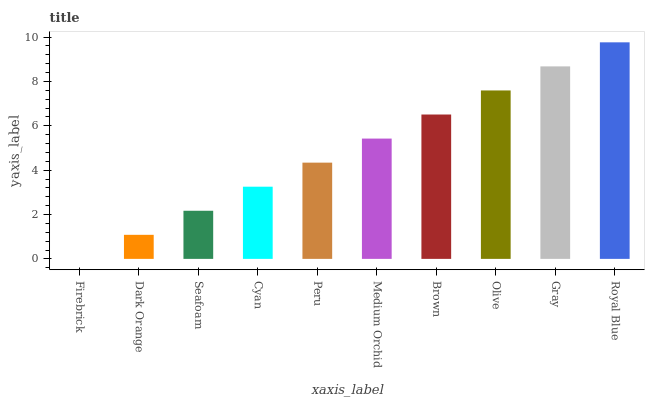Is Dark Orange the minimum?
Answer yes or no. No. Is Dark Orange the maximum?
Answer yes or no. No. Is Dark Orange greater than Firebrick?
Answer yes or no. Yes. Is Firebrick less than Dark Orange?
Answer yes or no. Yes. Is Firebrick greater than Dark Orange?
Answer yes or no. No. Is Dark Orange less than Firebrick?
Answer yes or no. No. Is Medium Orchid the high median?
Answer yes or no. Yes. Is Peru the low median?
Answer yes or no. Yes. Is Firebrick the high median?
Answer yes or no. No. Is Cyan the low median?
Answer yes or no. No. 